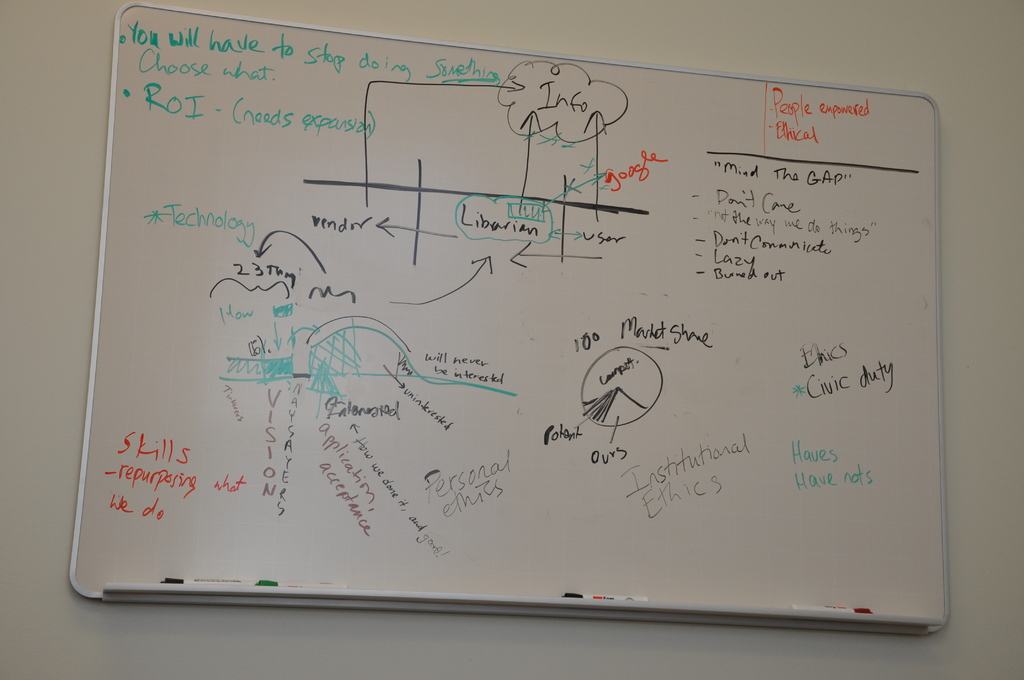Can you explain why 'Choose what to stop doing' is prominent on this whiteboard? The phrase 'Choose what to stop doing' is highlighted to emphasize the importance of prioritization and resource allocation within the organization. By identifying less impactful activities, the team can redirect their focus and resources towards initiatives that promise higher returns or strategic value, enhancing overall efficiency and effectiveness. How does the ROI notion fit into this scenario? ROI, or Return on Investment, is noted here needing expansion, signaling that the discussion is centered around measuring the effectiveness of investments or strategies. The team is likely analyzing which activities yield the best returns, aligning their efforts with financial goals to ensure sustainable growth and profitability. 